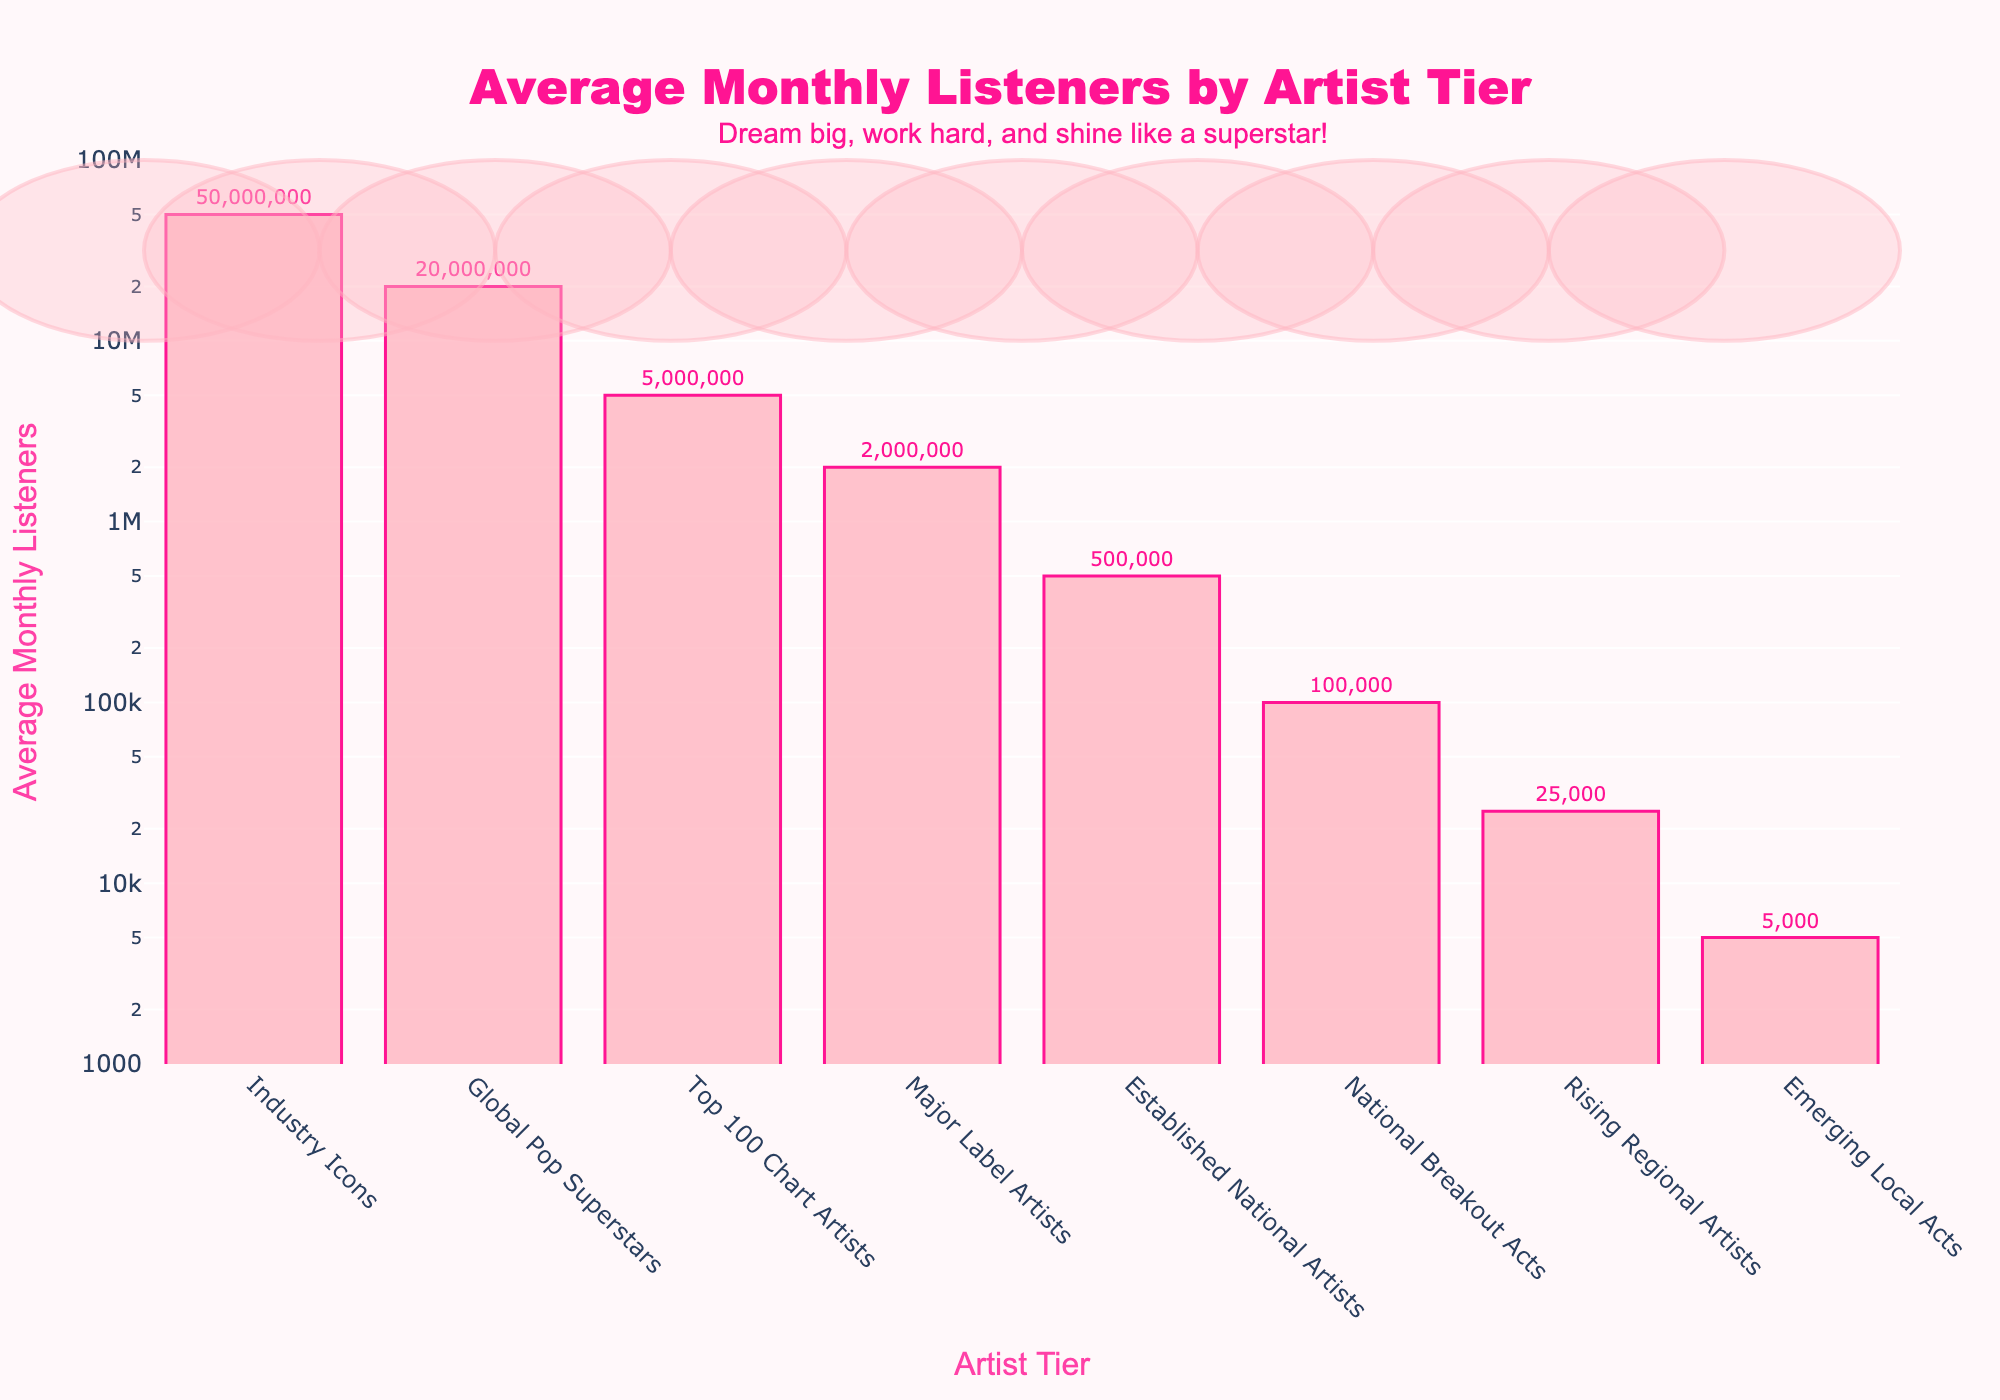How many times more average monthly listeners does a Global Pop Superstar have compared to a Major Label Artist? A Global Pop Superstar has 20,000,000 average monthly listeners, whereas a Major Label Artist has 2,000,000. To find out how many times more listeners, divide 20,000,000 by 2,000,000.
Answer: 10 Which artist tier has the lowest average monthly listeners? Look at the bar chart and identify the bar with the smallest height. This corresponds to the Emerging Local Acts.
Answer: Emerging Local Acts What is the difference in average monthly listeners between Industry Icons and Established National Artists? Industry Icons have 50,000,000 average monthly listeners, and Established National Artists have 500,000. Subtract the latter from the former.
Answer: 49,500,000 Arrange the artist tiers in ascending order of their average monthly listeners. List the artist tiers starting from the one with the least average monthly listeners to the one with the most, based on the heights of the bars.
Answer: Emerging Local Acts, Rising Regional Artists, National Breakout Acts, Established National Artists, Major Label Artists, Top 100 Chart Artists, Global Pop Superstars, Industry Icons By how much do the average monthly listeners of National Breakout Acts exceed those of Rising Regional Artists? National Breakout Acts have 100,000 average monthly listeners, and Rising Regional Artists have 25,000. Subtract the latter from the former.
Answer: 75,000 What is the ratio of average monthly listeners between Top 100 Chart Artists and Emerging Local Acts? Top 100 Chart Artists have 5,000,000 average monthly listeners, and Emerging Local Acts have 5,000. Divide 5,000,000 by 5,000.
Answer: 1,000 If you combine the average monthly listeners of Rising Regional Artists and National Breakout Acts, what is the total? Rising Regional Artists have 25,000 average monthly listeners, and National Breakout Acts have 100,000. Add these two numbers together.
Answer: 125,000 Which artist tier is directly below Top 100 Chart Artists in terms of average monthly listeners? Identify the bar just below the bar representing Top 100 Chart Artists. This corresponds to Major Label Artists.
Answer: Major Label Artists What is the approximate average monthly listeners difference between each successive tier from National Breakout Acts up to Industry Icons? Starting from National Breakout Acts (100,000), the next tiers are Established National Artists (500,000), Major Label Artists (2,000,000), Top 100 Chart Artists (5,000,000), Global Pop Superstars (20,000,000), and Industry Icons (50,000,000). Calculate the differences: (500,000 - 100,000), (2,000,000 - 500,000), (5,000,000 - 2,000,000), (20,000,000 - 5,000,000), (50,000,000 - 20,000,000). Average these differences.
Answer: 8,760,000 